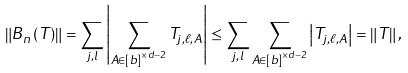<formula> <loc_0><loc_0><loc_500><loc_500>\left \| B _ { n } \left ( T \right ) \right \| = \sum _ { j , l } \left | \sum _ { A \in \left [ b \right ] ^ { \times d - 2 } } T _ { j , \ell , A } \right | \leq \sum _ { j , l } \sum _ { A \in \left [ b \right ] ^ { \times d - 2 } } \left | T _ { j , \ell , A } \right | = \left \| T \right \| ,</formula> 